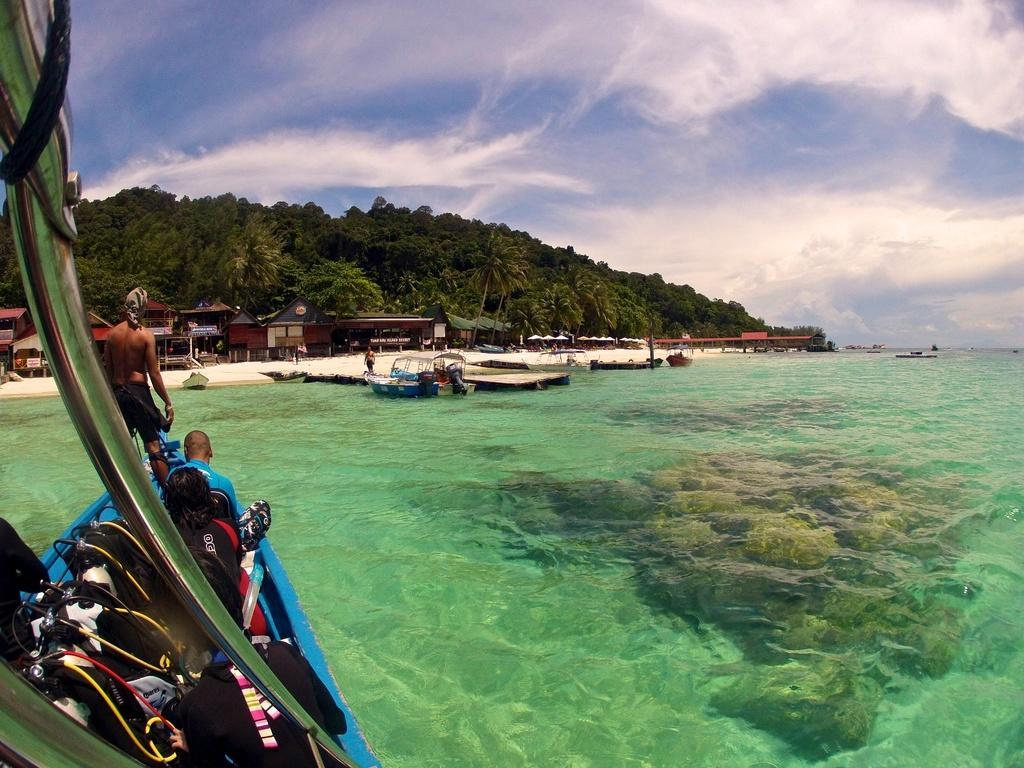Can you describe this image briefly? There is a sea at the bottom of the image. We can see a boat and people on the left side of the image. In the background, we can see houses, boats, dock, land, mountains and trees. At the top of the image, we can see the sky with clouds. 